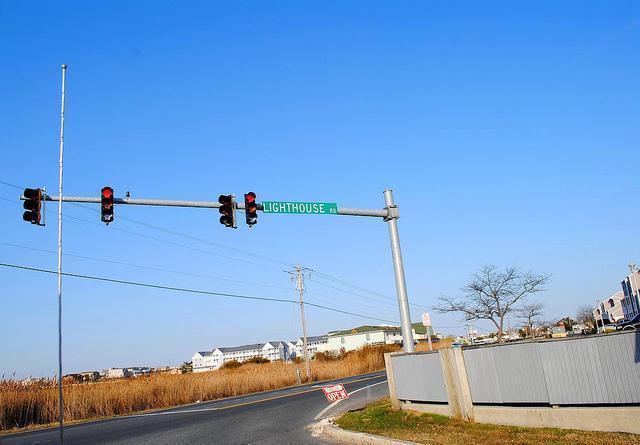How many people are on the pommel lift?
Give a very brief answer. 0. 